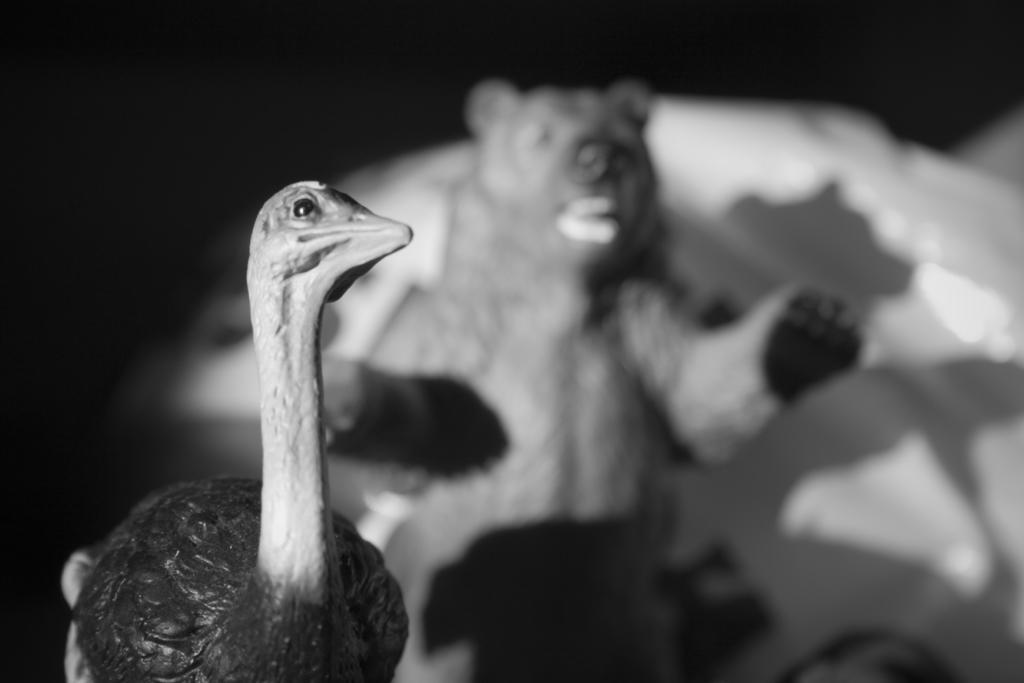Can you describe this image briefly? It is a black and white picture. In the image in the center, we can see one bird and one animal. 